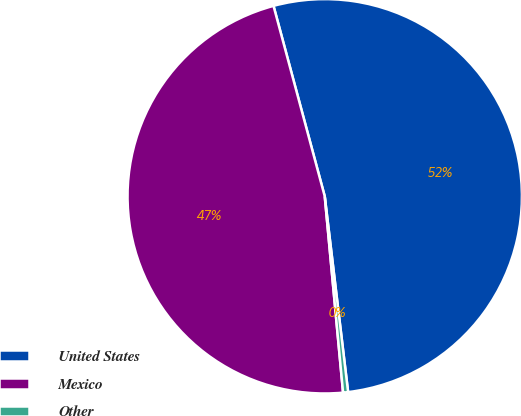<chart> <loc_0><loc_0><loc_500><loc_500><pie_chart><fcel>United States<fcel>Mexico<fcel>Other<nl><fcel>52.29%<fcel>47.3%<fcel>0.41%<nl></chart> 